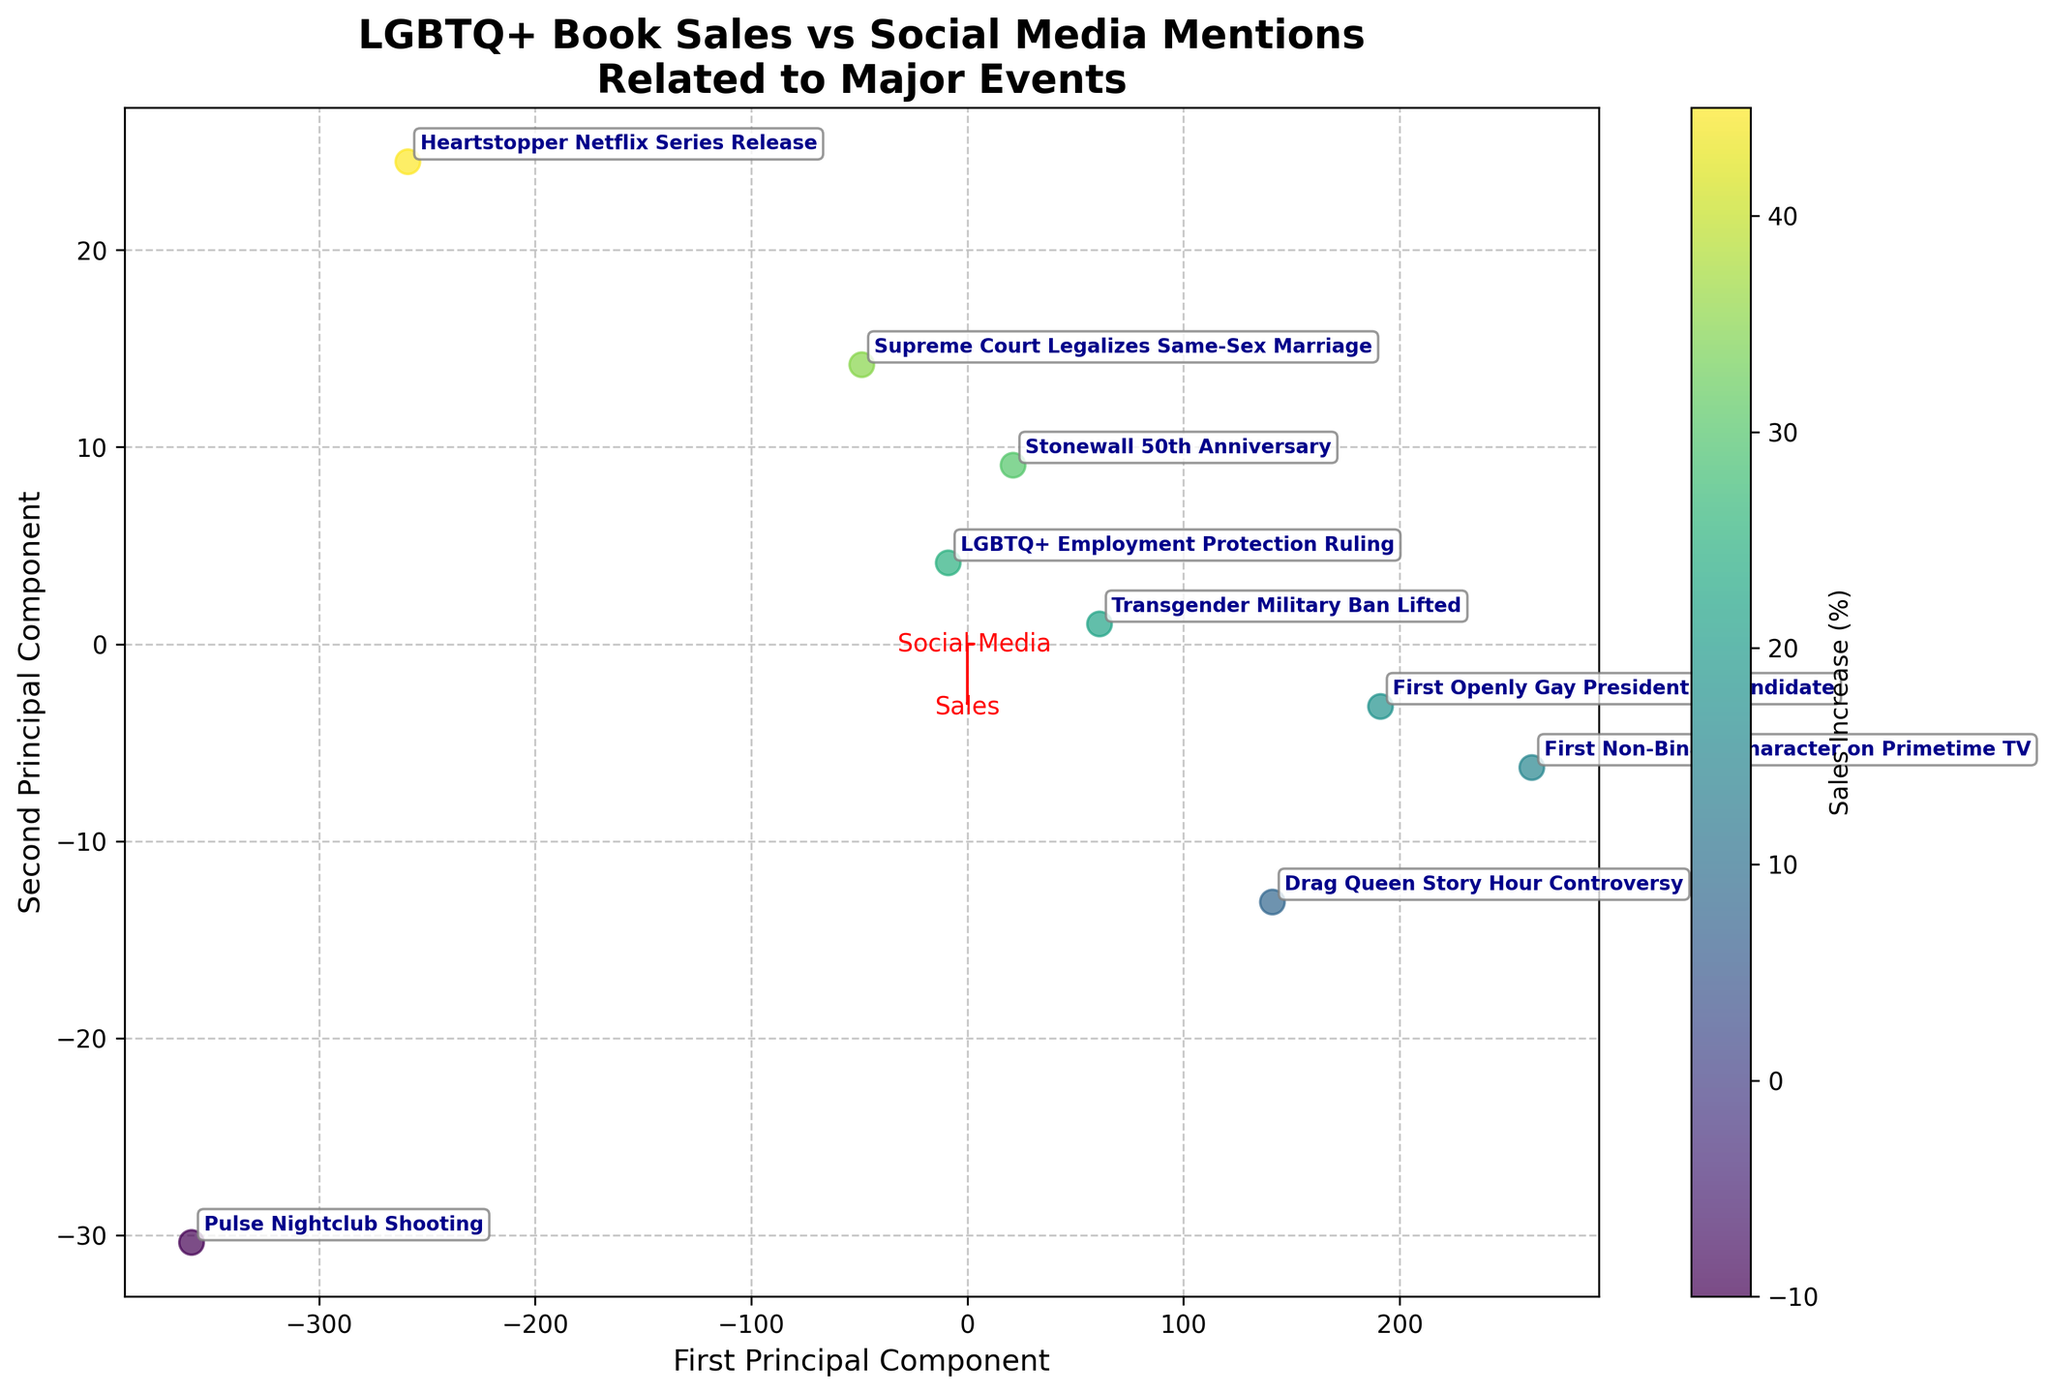What is the title of the figure? Look at the top of the plot; the title is centered and should provide a quick summary of the chart's purpose.
Answer: LGBTQ+ Book Sales vs Social Media Mentions Related to Major Events How many major events are represented on the biplot? Count the total number of labeled points in the plot, each representing a different event.
Answer: 9 Which event had the highest sales increase (%)? Identify the data point with the highest value for the colorbar which represents sales increase.
Answer: "Heartstopper" Netflix Series Release Which event had the lowest sales increase (%)? Identify the data point with the lowest value for the colorbar which represents sales increase.
Answer: Pulse Nightclub Shooting What is the relation between 'Sales Increase (%)' and 'Social Media Mentions (thousands)' according to the principal component vectors? Analyze the direction and length of the arrows labeled 'Sales' and 'Social Media'. Both the direction and length provide information about how these variables contribute to the principal components.
Answer: Positive correlation, both vectors point similarly Which events have similar social media mentions (close in value) but different sales increases? Look for points that are close to each other on the PC axis associated with social media mentions but have distinct colors representing different sales increase percentages.
Answer: Supreme Court Legalizes Same-Sex Marriage and Stonewall 50th Anniversary How does the 'First Openly Gay Presidential Candidate' event compare to 'Drag Queen Story Hour Controversy' in terms of both sales increases and social media mentions? Compare the position and color of these two data points on the biplot. 'First Openly Gay Presidential Candidate' should be farther to the right and higher in value.
Answer: Higher in both sales increase and social media mentions What is the approximate principal component value for the event 'Transgender Military Ban Lifted'? Locate this event on the plot and approximate its position on both the principal components' axes.
Answer: PC1 ≈ 1.5, PC2 ≈ -0.5 Is there any event with a negative sales increase percentage? If so, which event is it? Examine the color-coded sales increase percentages; identify any event colored to indicate a negative value.
Answer: Pulse Nightclub Shooting 